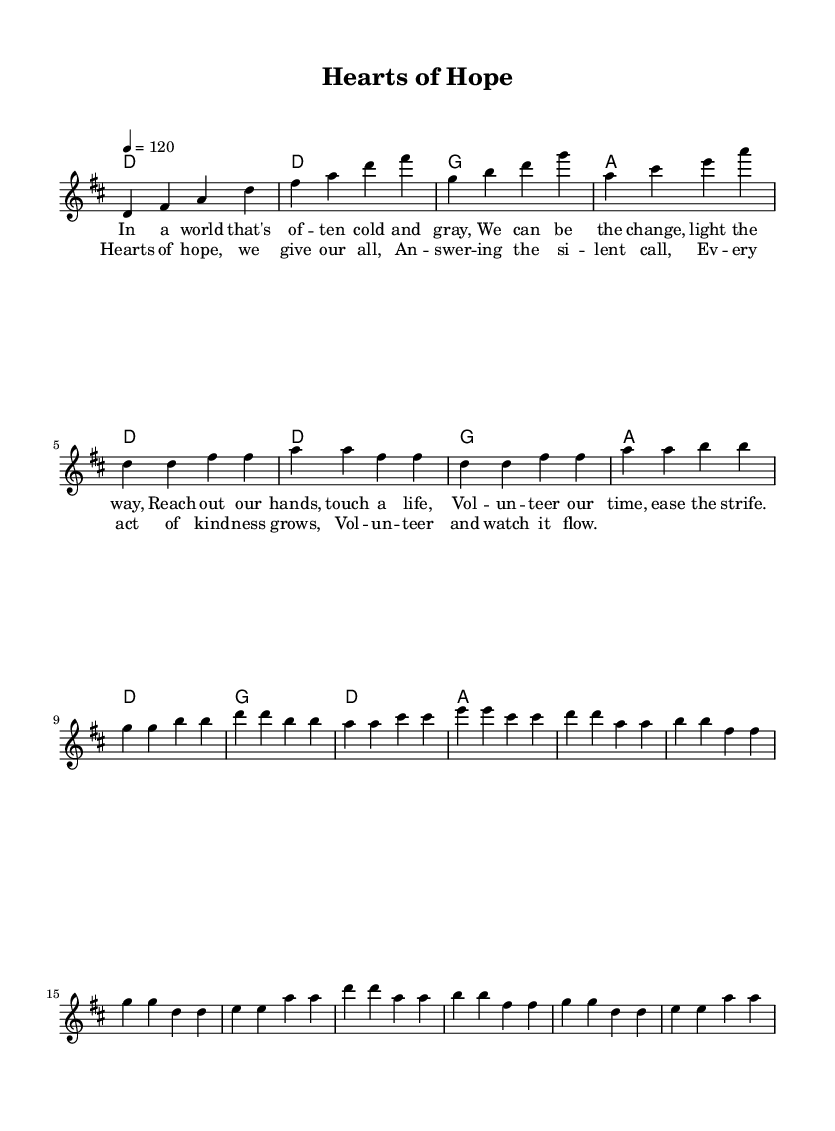What is the key signature of this music? The key signature is identified by looking at the beginning of the staff, where there are two sharps (F# and C#). This indicates the key of D major.
Answer: D major What is the time signature of this music? The time signature is shown at the beginning of the music, represented as 4/4. This indicates that there are four beats in each measure and a quarter note gets one beat.
Answer: 4/4 What is the tempo marking for this piece? The tempo is indicated below the clef in the form of a metronome marking, which reads "4 = 120." This tells performers to play quarter notes at a speed of 120 beats per minute.
Answer: 120 How many measures are in the verse section? By counting each of the measures in the verse section, we see that there are six distinct measures presented in the verse.
Answer: 6 What is the main theme of the chorus lyrics? The lyrics in the chorus focus on themes of hope and volunteerism, emphasizing kindness and responding to needs in the community. This is derived from phrases like "hearts of hope" and "answering the silent call."
Answer: Hope and volunteerism What is the chord progression used in the chorus? The chord progression can be identified by looking at the harmonies written above the melody during the chorus section, which states D, G, D, A. This showcases a common pattern in punk music designed to enhance emotional impact.
Answer: D, G, D, A How do the verses differ in structure from the chorus? The verses have a more narrative structure focusing on storytelling, while the chorus is structured to be repetitive and uplifting, often featuring a rhythmic and lyrical contrast that emphasizes the song's message. This can be seen by contrasting their lyrical content and the repeated patterns in the chorus.
Answer: Structure contrast 